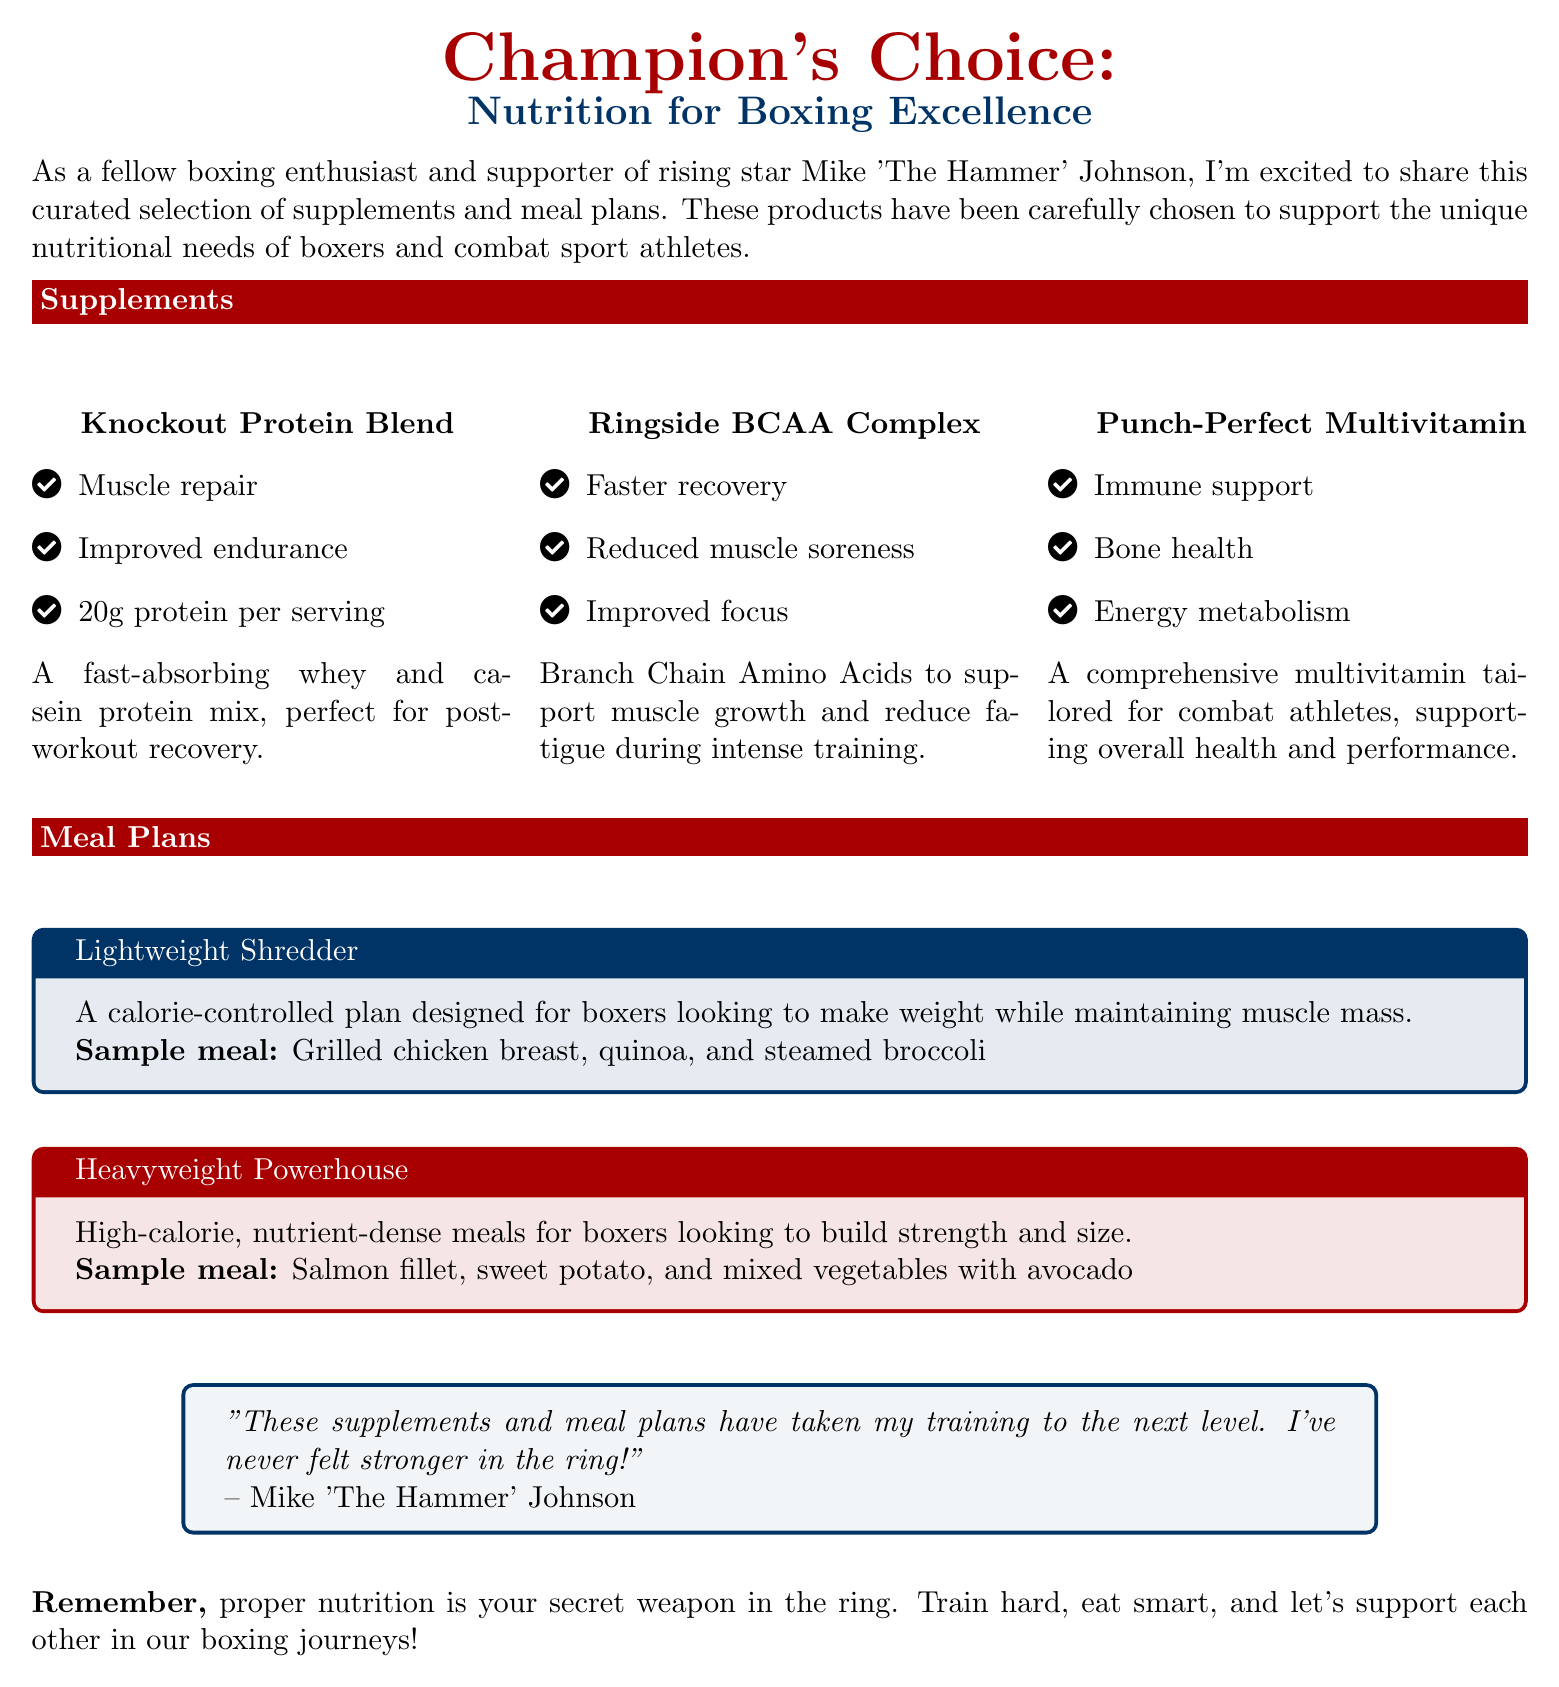what is the name of the protein supplement? The name of the protein supplement listed in the document is "Knockout Protein Blend."
Answer: Knockout Protein Blend how many grams of protein per serving does the Knockout Protein Blend provide? The document states that the Knockout Protein Blend provides 20g of protein per serving.
Answer: 20g what are the key benefits of the Ringside BCAA Complex? The Ringside BCAA Complex is noted for faster recovery, reduced muscle soreness, and improved focus.
Answer: Faster recovery, reduced muscle soreness, improved focus which meal plan is designed for boxers looking to make weight? The meal plan designed for boxers looking to make weight is called "Lightweight Shredder."
Answer: Lightweight Shredder what is a sample meal from the Heavyweight Powerhouse plan? The sample meal from the Heavyweight Powerhouse plan is "Salmon fillet, sweet potato, and mixed vegetables with avocado."
Answer: Salmon fillet, sweet potato, and mixed vegetables with avocado who endorsed the meal plans and supplements in the document? The endorsement in the document is from Mike 'The Hammer' Johnson.
Answer: Mike 'The Hammer' Johnson how is the Punch-Perfect Multivitamin described in terms of its purpose? The Punch-Perfect Multivitamin is described as supporting immune health, bone health, and energy metabolism.
Answer: Immune support, bone health, energy metabolism what is the general message conveyed at the end of the document? The general message emphasizes the importance of proper nutrition as a secret weapon in training and encouragement to support each other.
Answer: Proper nutrition is your secret weapon in the ring 